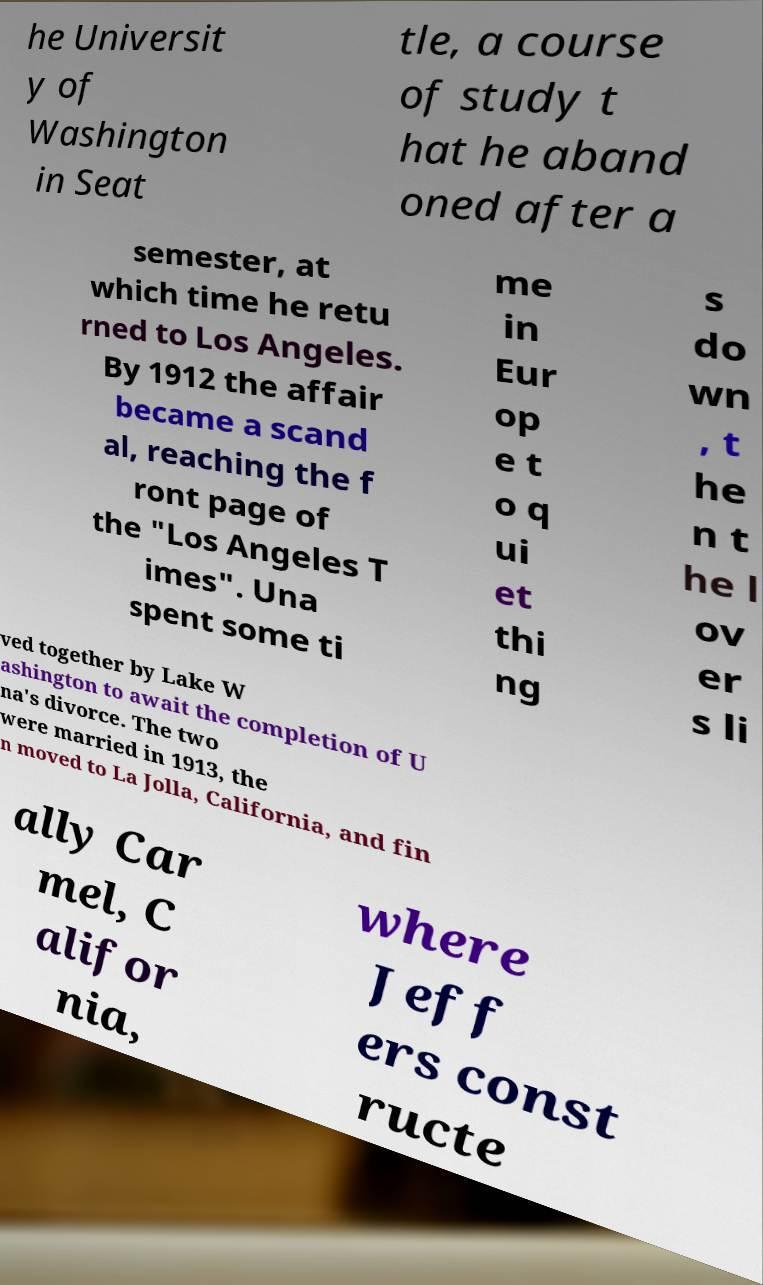Can you accurately transcribe the text from the provided image for me? he Universit y of Washington in Seat tle, a course of study t hat he aband oned after a semester, at which time he retu rned to Los Angeles. By 1912 the affair became a scand al, reaching the f ront page of the "Los Angeles T imes". Una spent some ti me in Eur op e t o q ui et thi ng s do wn , t he n t he l ov er s li ved together by Lake W ashington to await the completion of U na's divorce. The two were married in 1913, the n moved to La Jolla, California, and fin ally Car mel, C alifor nia, where Jeff ers const ructe 